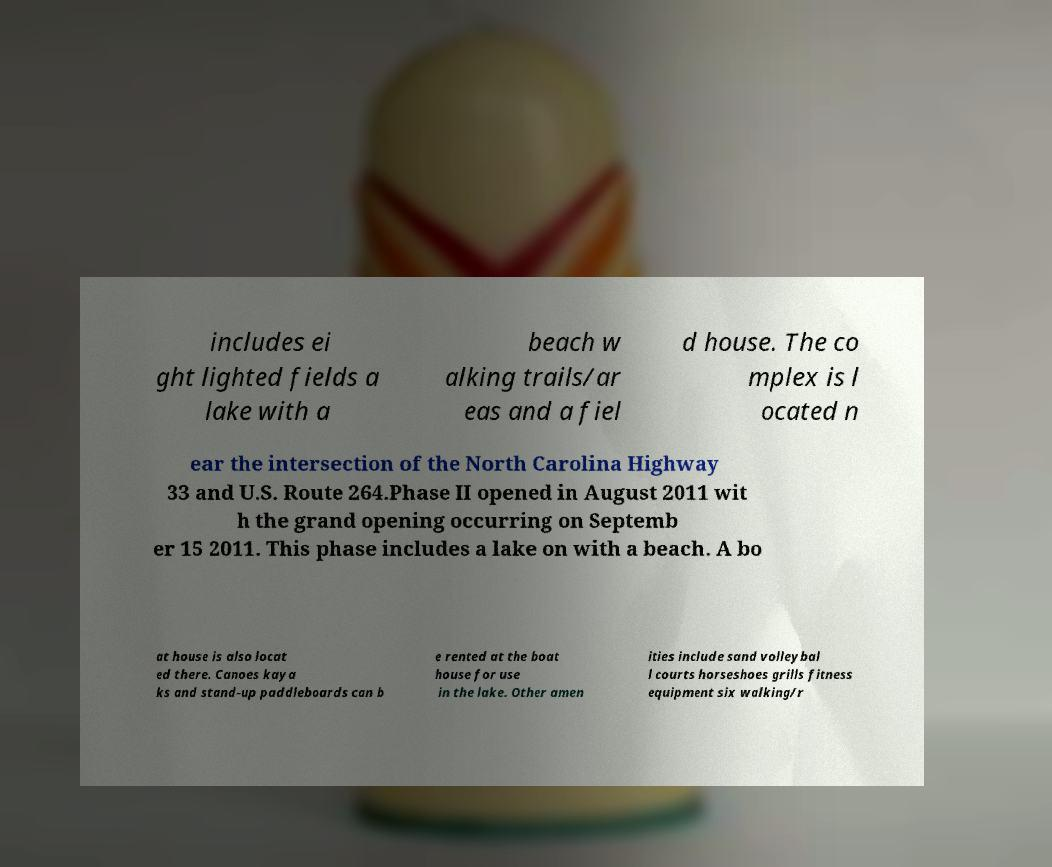Can you accurately transcribe the text from the provided image for me? includes ei ght lighted fields a lake with a beach w alking trails/ar eas and a fiel d house. The co mplex is l ocated n ear the intersection of the North Carolina Highway 33 and U.S. Route 264.Phase II opened in August 2011 wit h the grand opening occurring on Septemb er 15 2011. This phase includes a lake on with a beach. A bo at house is also locat ed there. Canoes kaya ks and stand-up paddleboards can b e rented at the boat house for use in the lake. Other amen ities include sand volleybal l courts horseshoes grills fitness equipment six walking/r 